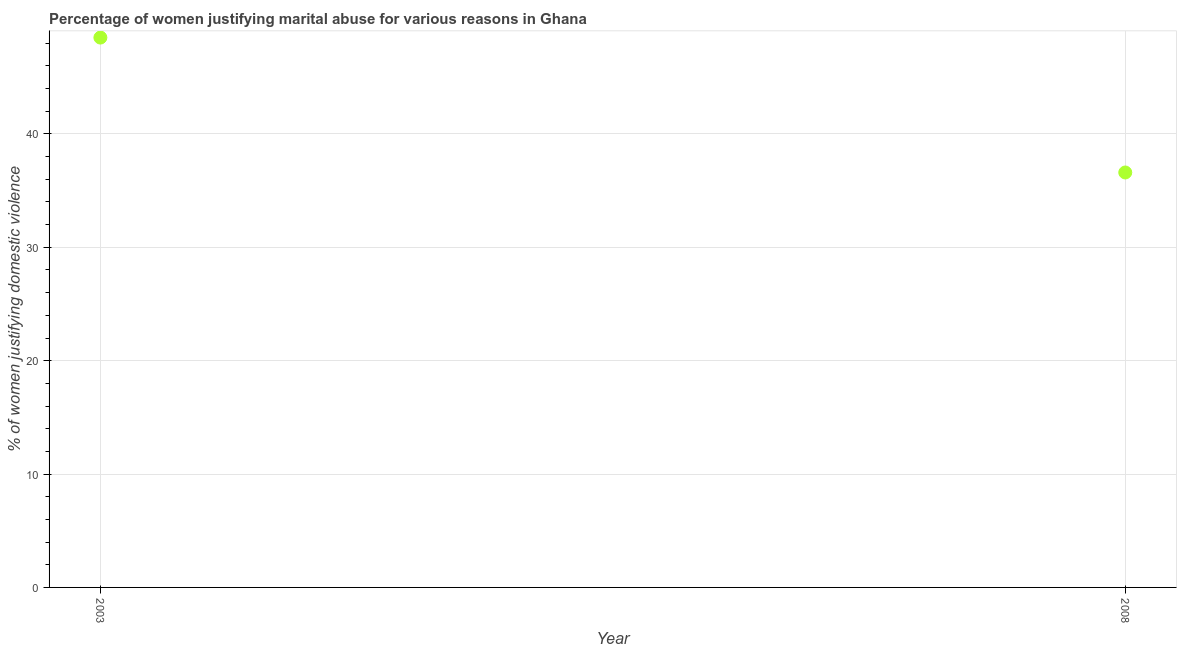What is the percentage of women justifying marital abuse in 2003?
Provide a short and direct response. 48.5. Across all years, what is the maximum percentage of women justifying marital abuse?
Provide a short and direct response. 48.5. Across all years, what is the minimum percentage of women justifying marital abuse?
Your response must be concise. 36.6. In which year was the percentage of women justifying marital abuse maximum?
Make the answer very short. 2003. In which year was the percentage of women justifying marital abuse minimum?
Make the answer very short. 2008. What is the sum of the percentage of women justifying marital abuse?
Provide a short and direct response. 85.1. What is the difference between the percentage of women justifying marital abuse in 2003 and 2008?
Offer a very short reply. 11.9. What is the average percentage of women justifying marital abuse per year?
Offer a terse response. 42.55. What is the median percentage of women justifying marital abuse?
Ensure brevity in your answer.  42.55. In how many years, is the percentage of women justifying marital abuse greater than 18 %?
Provide a succinct answer. 2. What is the ratio of the percentage of women justifying marital abuse in 2003 to that in 2008?
Your answer should be very brief. 1.33. Is the percentage of women justifying marital abuse in 2003 less than that in 2008?
Ensure brevity in your answer.  No. In how many years, is the percentage of women justifying marital abuse greater than the average percentage of women justifying marital abuse taken over all years?
Keep it short and to the point. 1. How many dotlines are there?
Make the answer very short. 1. Are the values on the major ticks of Y-axis written in scientific E-notation?
Ensure brevity in your answer.  No. Does the graph contain grids?
Keep it short and to the point. Yes. What is the title of the graph?
Offer a terse response. Percentage of women justifying marital abuse for various reasons in Ghana. What is the label or title of the X-axis?
Provide a short and direct response. Year. What is the label or title of the Y-axis?
Your response must be concise. % of women justifying domestic violence. What is the % of women justifying domestic violence in 2003?
Ensure brevity in your answer.  48.5. What is the % of women justifying domestic violence in 2008?
Provide a short and direct response. 36.6. What is the ratio of the % of women justifying domestic violence in 2003 to that in 2008?
Offer a very short reply. 1.32. 